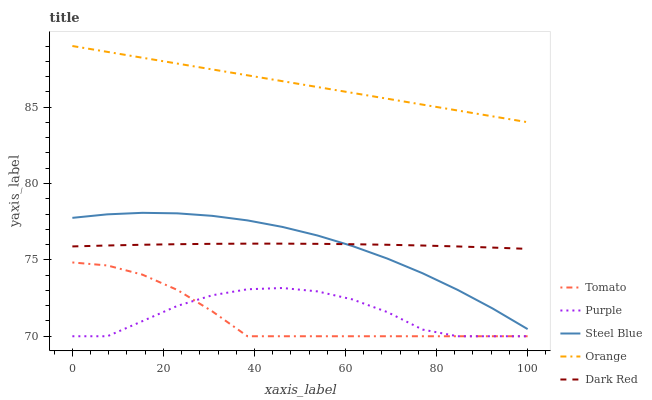Does Tomato have the minimum area under the curve?
Answer yes or no. Yes. Does Orange have the maximum area under the curve?
Answer yes or no. Yes. Does Purple have the minimum area under the curve?
Answer yes or no. No. Does Purple have the maximum area under the curve?
Answer yes or no. No. Is Orange the smoothest?
Answer yes or no. Yes. Is Purple the roughest?
Answer yes or no. Yes. Is Purple the smoothest?
Answer yes or no. No. Is Orange the roughest?
Answer yes or no. No. Does Tomato have the lowest value?
Answer yes or no. Yes. Does Orange have the lowest value?
Answer yes or no. No. Does Orange have the highest value?
Answer yes or no. Yes. Does Purple have the highest value?
Answer yes or no. No. Is Tomato less than Dark Red?
Answer yes or no. Yes. Is Dark Red greater than Tomato?
Answer yes or no. Yes. Does Steel Blue intersect Dark Red?
Answer yes or no. Yes. Is Steel Blue less than Dark Red?
Answer yes or no. No. Is Steel Blue greater than Dark Red?
Answer yes or no. No. Does Tomato intersect Dark Red?
Answer yes or no. No. 